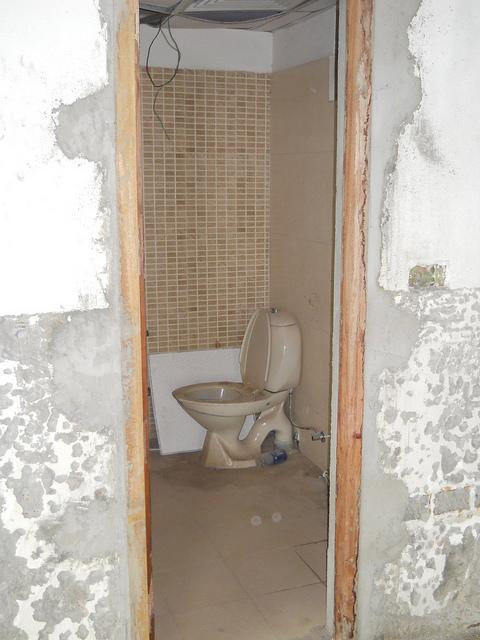How many people are shown?
Give a very brief answer. 0. 